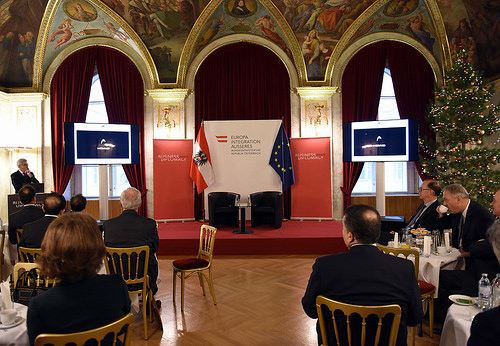<image>
Is there a man on the chair? No. The man is not positioned on the chair. They may be near each other, but the man is not supported by or resting on top of the chair. 